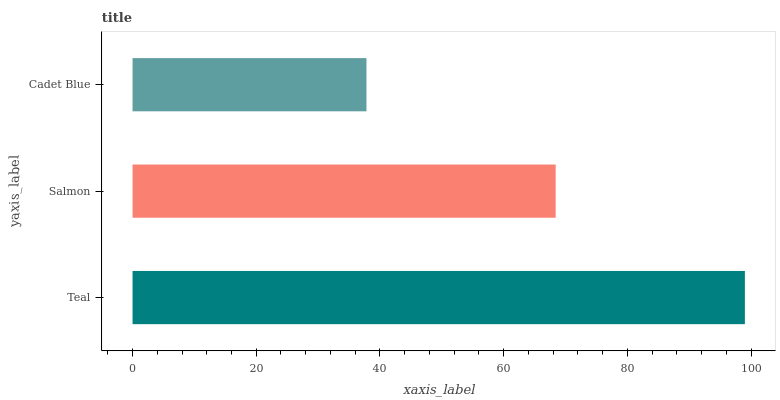Is Cadet Blue the minimum?
Answer yes or no. Yes. Is Teal the maximum?
Answer yes or no. Yes. Is Salmon the minimum?
Answer yes or no. No. Is Salmon the maximum?
Answer yes or no. No. Is Teal greater than Salmon?
Answer yes or no. Yes. Is Salmon less than Teal?
Answer yes or no. Yes. Is Salmon greater than Teal?
Answer yes or no. No. Is Teal less than Salmon?
Answer yes or no. No. Is Salmon the high median?
Answer yes or no. Yes. Is Salmon the low median?
Answer yes or no. Yes. Is Teal the high median?
Answer yes or no. No. Is Teal the low median?
Answer yes or no. No. 